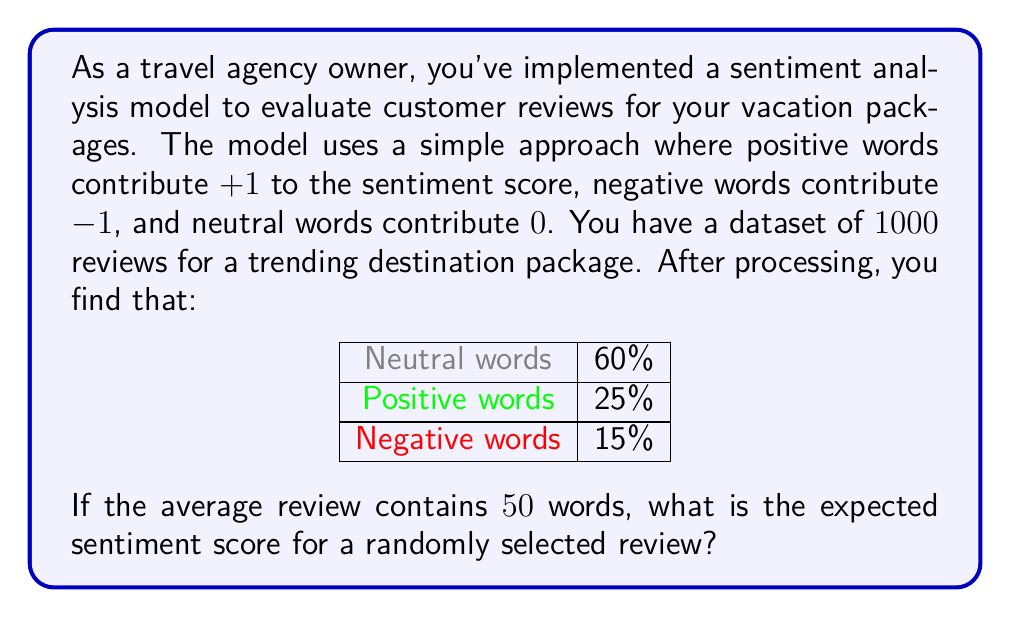Give your solution to this math problem. Let's approach this step-by-step:

1) First, let's define our variables:
   $n$ = total number of words per review = 50
   $p_{pos}$ = proportion of positive words = 0.25
   $p_{neg}$ = proportion of negative words = 0.15
   $p_{neu}$ = proportion of neutral words = 0.60

2) We can calculate the expected number of each type of word in a review:
   Positive words: $n_{pos} = n \times p_{pos} = 50 \times 0.25 = 12.5$
   Negative words: $n_{neg} = n \times p_{neg} = 50 \times 0.15 = 7.5$
   Neutral words: $n_{neu} = n \times p_{neu} = 50 \times 0.60 = 30$

3) Now, let's recall how each type of word contributes to the sentiment score:
   Positive words: +1
   Negative words: -1
   Neutral words: 0

4) The expected sentiment score can be calculated as:
   $$E[\text{sentiment}] = (+1 \times n_{pos}) + (-1 \times n_{neg}) + (0 \times n_{neu})$$

5) Substituting our values:
   $$E[\text{sentiment}] = (+1 \times 12.5) + (-1 \times 7.5) + (0 \times 30)$$

6) Simplifying:
   $$E[\text{sentiment}] = 12.5 - 7.5 = 5$$

Therefore, the expected sentiment score for a randomly selected review is 5.
Answer: 5 